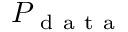<formula> <loc_0><loc_0><loc_500><loc_500>P _ { d a t a }</formula> 